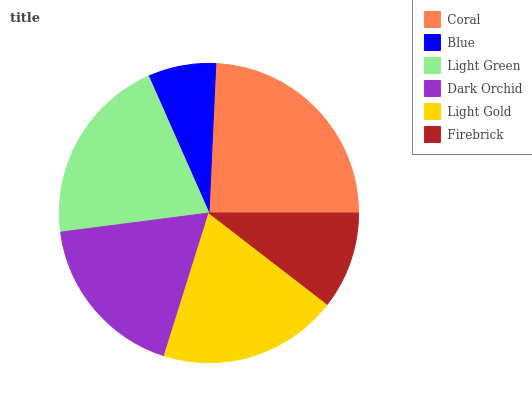Is Blue the minimum?
Answer yes or no. Yes. Is Coral the maximum?
Answer yes or no. Yes. Is Light Green the minimum?
Answer yes or no. No. Is Light Green the maximum?
Answer yes or no. No. Is Light Green greater than Blue?
Answer yes or no. Yes. Is Blue less than Light Green?
Answer yes or no. Yes. Is Blue greater than Light Green?
Answer yes or no. No. Is Light Green less than Blue?
Answer yes or no. No. Is Light Gold the high median?
Answer yes or no. Yes. Is Dark Orchid the low median?
Answer yes or no. Yes. Is Dark Orchid the high median?
Answer yes or no. No. Is Firebrick the low median?
Answer yes or no. No. 